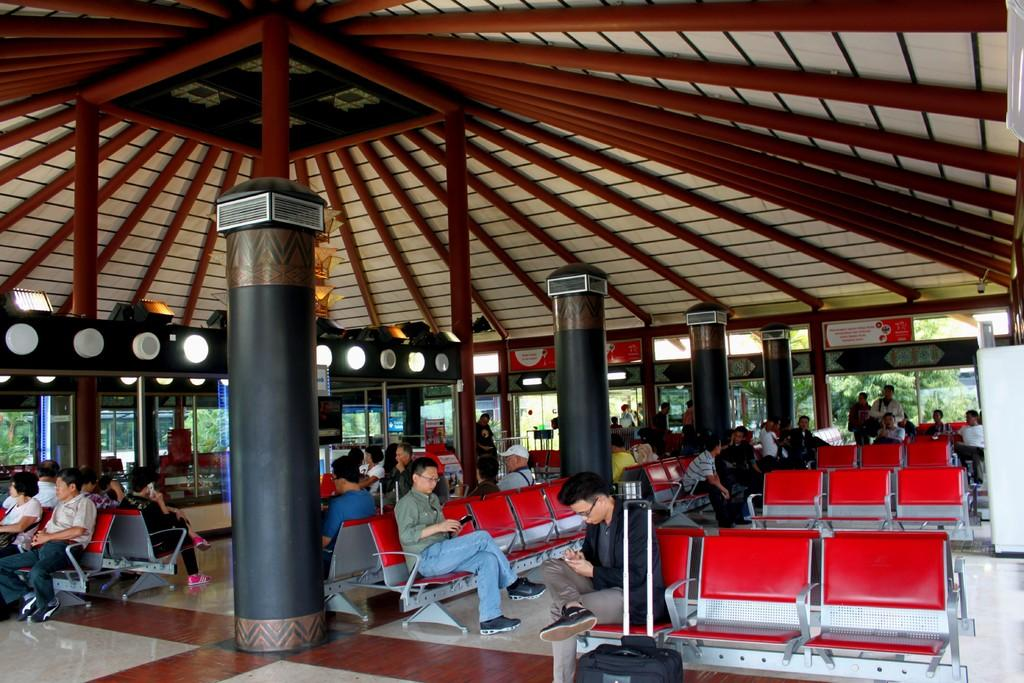What are the people in the image doing? People are sitting on chairs in the image. Can you describe the man in the image? There is a man with luggage in the image. What architectural feature can be seen in the image? There is a pillar in the image. What type of lighting is present in the image? There are lights in the image. What type of windows are present in the image? Glass windows are present in the image. What can be seen through the glass windows? Trees are visible through the glass windows. What type of canvas is the man painting in the image? There is no canvas or painting activity present in the image. How does the man carry his luggage while swimming in the image? There is no swimming or luggage-carrying activity present in the image. 